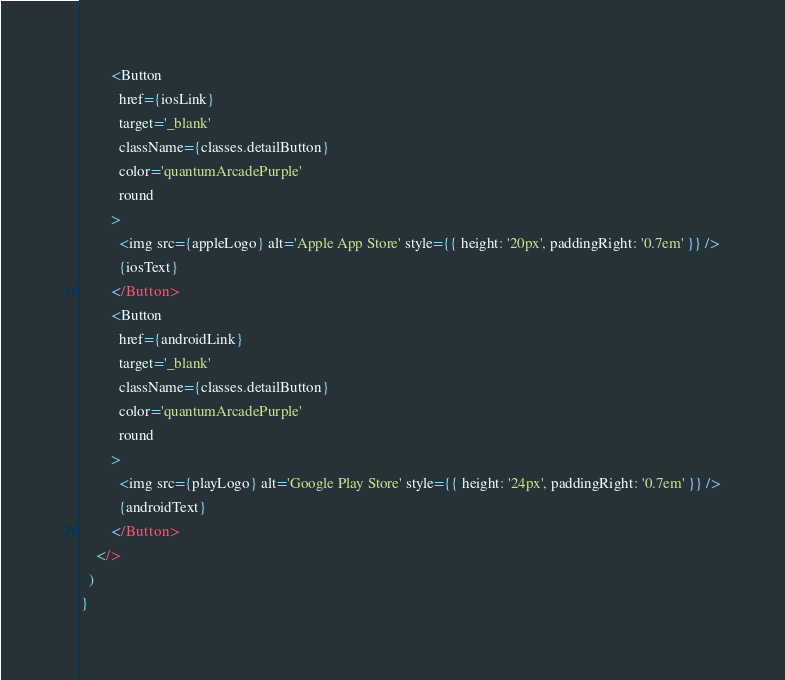<code> <loc_0><loc_0><loc_500><loc_500><_JavaScript_>        <Button
          href={iosLink}
          target='_blank'
          className={classes.detailButton}
          color='quantumArcadePurple'
          round
        >
          <img src={appleLogo} alt='Apple App Store' style={{ height: '20px', paddingRight: '0.7em' }} />
          {iosText}
        </Button>
        <Button
          href={androidLink}
          target='_blank'
          className={classes.detailButton}
          color='quantumArcadePurple'
          round
        >
          <img src={playLogo} alt='Google Play Store' style={{ height: '24px', paddingRight: '0.7em' }} />
          {androidText}
        </Button>
    </>
  )
}</code> 